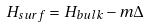Convert formula to latex. <formula><loc_0><loc_0><loc_500><loc_500>H _ { s u r f } = H _ { b u l k } - m \Delta</formula> 